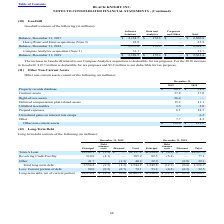From Black Knight Financial Services's financial document, Which years does the table provide information for other non-current assets of the company? The document shows two values: 2019 and 2018. From the document: "2019 2018 2019 2018..." Also, What were the amount of contract assets in 2019? According to the financial document, 37.8 (in millions). The relevant text states: "Contract assets 37.8 17.0..." Also, What was the amount of right-of-use assets in 2019? According to the financial document, 26.4 (in millions). The relevant text states: "Right-of-use assets 26.4 —..." Also, can you calculate: What was the change in prepaid expenses between 2018 and 2019? Based on the calculation: 8.1-18.3, the result is -10.2 (in millions). This is based on the information: "Prepaid expenses 8.1 18.3 Prepaid expenses 8.1 18.3..." The key data points involved are: 18.3, 8.1. Also, can you calculate: What was the change in unbilled receivables between 2018 and 2019? Based on the calculation: 3.5-5.0, the result is -1.5 (in millions). This is based on the information: "Unbilled receivables 3.5 5.0 Unbilled receivables 3.5 5.0..." The key data points involved are: 3.5, 5.0. Also, can you calculate: What was the percentage change in the total other non-current assets between 2018 and 2019? To answer this question, I need to perform calculations using the financial data. The calculation is: (158.8-121.8)/121.8, which equals 30.38 (percentage). This is based on the information: "Other non-current assets $ 158.8 $ 121.8 Other non-current assets $ 158.8 $ 121.8..." The key data points involved are: 121.8, 158.8. 